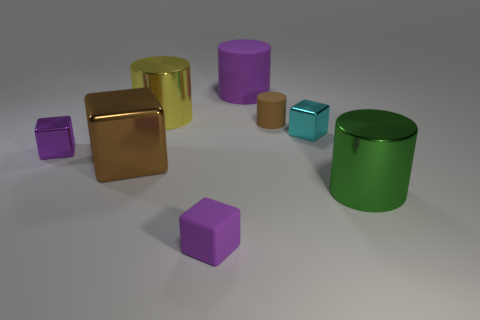Subtract all big cylinders. How many cylinders are left? 1 Subtract 2 blocks. How many blocks are left? 2 Subtract all blue cylinders. How many brown blocks are left? 1 Subtract all cyan cylinders. Subtract all brown metallic cubes. How many objects are left? 7 Add 7 purple metallic things. How many purple metallic things are left? 8 Add 2 matte cubes. How many matte cubes exist? 3 Add 1 large purple rubber objects. How many objects exist? 9 Subtract all green cylinders. How many cylinders are left? 3 Subtract 0 red cylinders. How many objects are left? 8 Subtract all yellow blocks. Subtract all blue spheres. How many blocks are left? 4 